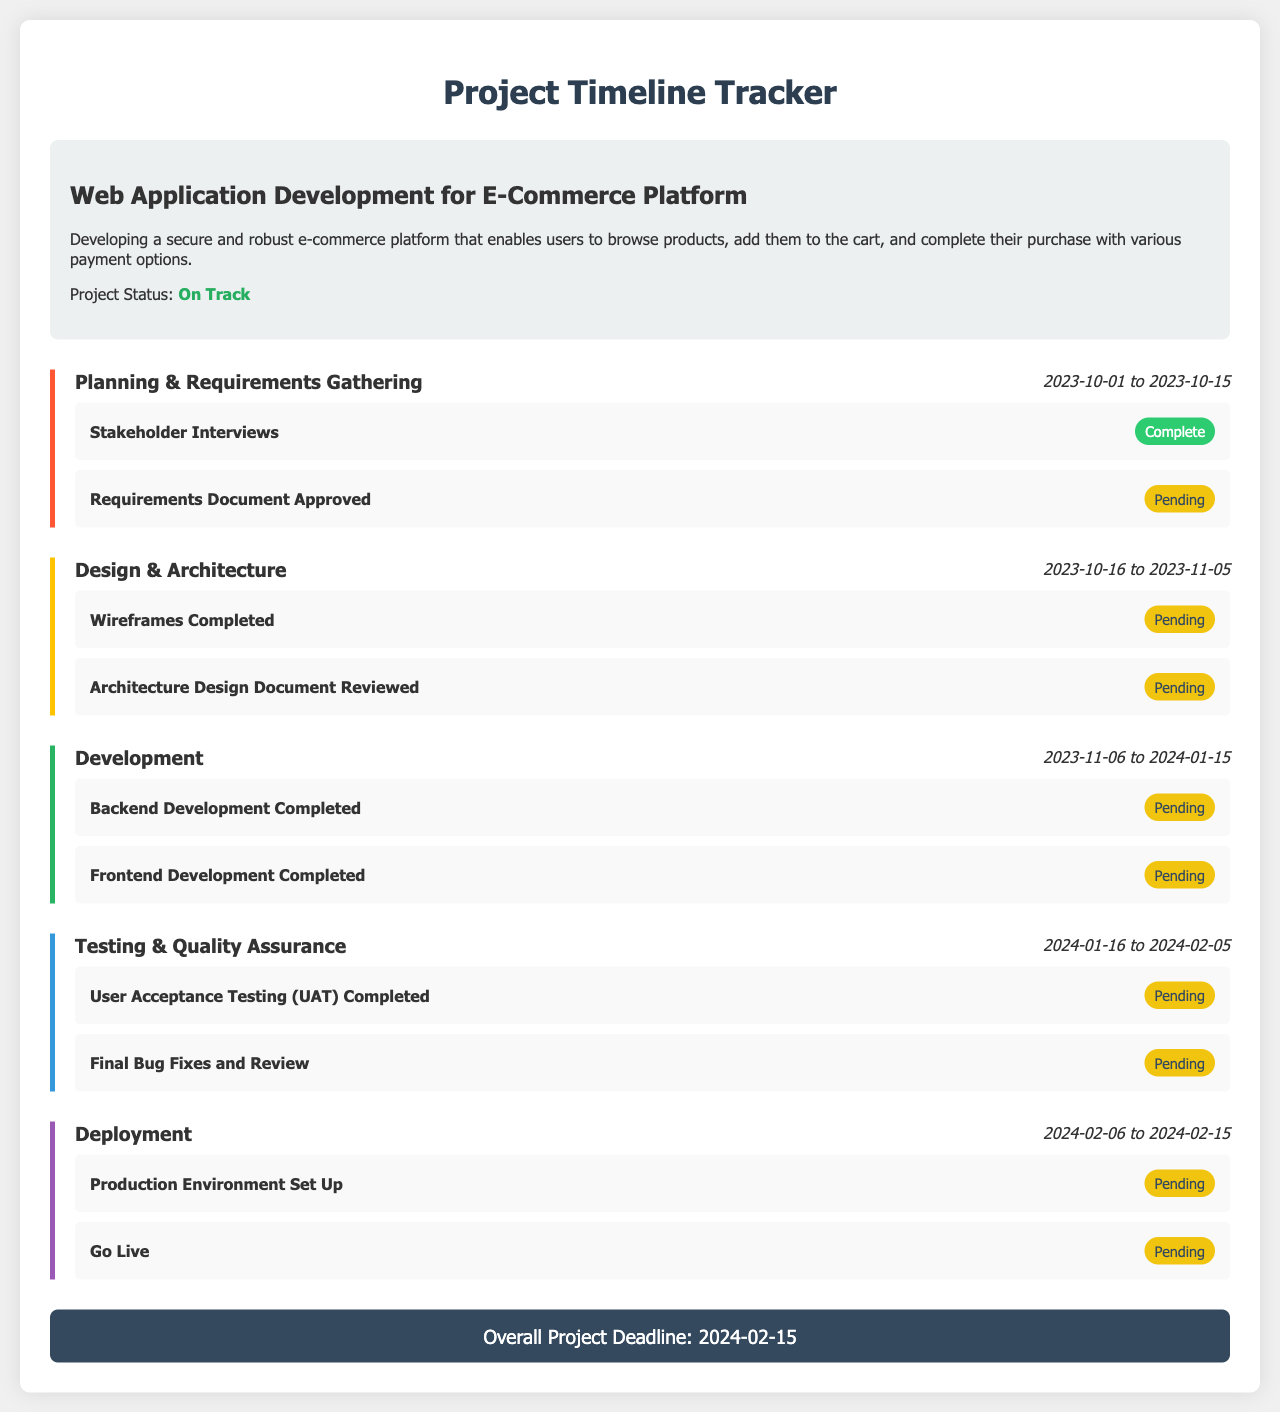What is the project title? The project title is mentioned at the top of the project info section in the document.
Answer: Web Application Development for E-Commerce Platform What is the status of the project? The project status indicates the current progress of the project in the project info section.
Answer: On Track What are the dates for the Planning & Requirements Gathering phase? The dates for each phase are provided alongside the phase names in the document.
Answer: 2023-10-01 to 2023-10-15 How many milestones are complete in the Design & Architecture phase? The complete milestones can be counted by checking their statuses in the Design & Architecture phase.
Answer: 0 What is the overall project deadline? The overall project deadline is positioned at the end of the document and summarizes the completion date of the project.
Answer: 2024-02-15 Which milestone is pending in the Development phase? The milestones are listed with their statuses in the Development phase; pending ones can be identified by their status.
Answer: Backend Development Completed What is the color code for the Testing & Quality Assurance phase? Each phase has a unique border color that can be found in the document indicating its category.
Answer: #3498DB Which milestone comes after "Production Environment Set Up" in the Deployment phase? Milestones are listed in order under their respective phases, and the one following is identified from that list.
Answer: Go Live How long is the Design & Architecture phase? The duration can be calculated based on the start and end dates provided for the phase.
Answer: 21 days 